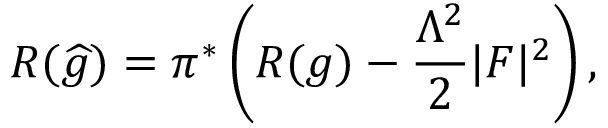<formula> <loc_0><loc_0><loc_500><loc_500>R ( { \widehat { g } } ) = \pi ^ { * } \left ( R ( g ) - { \frac { \Lambda ^ { 2 } } { 2 } } | F | ^ { 2 } \right ) ,</formula> 